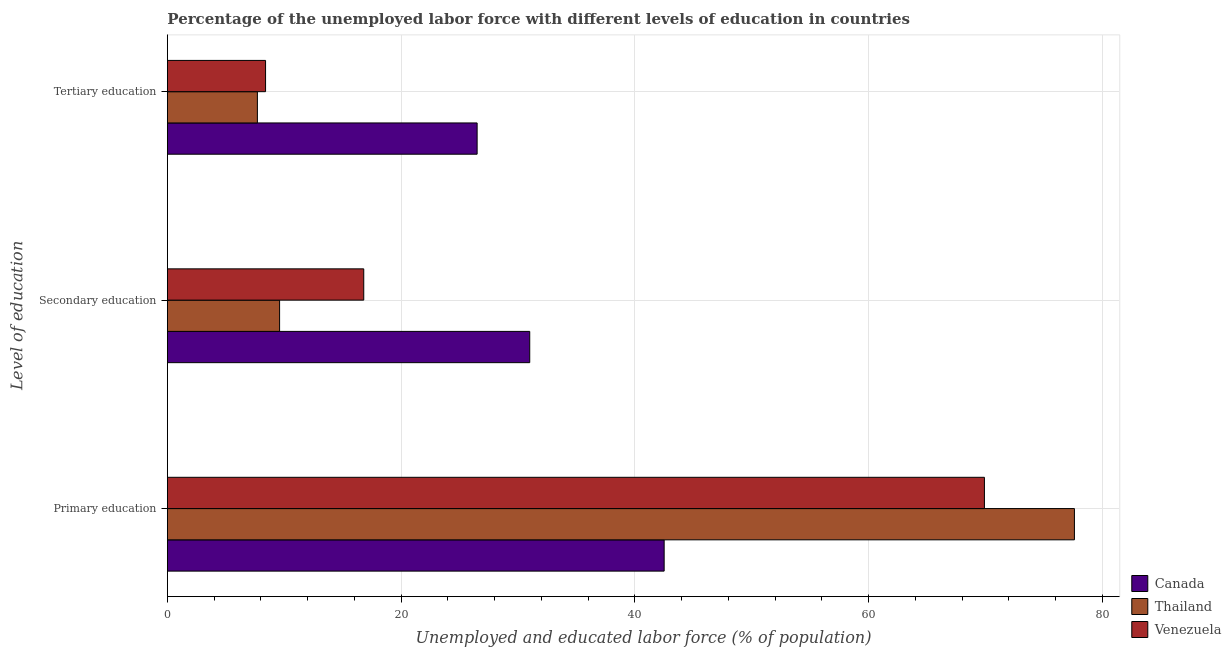How many different coloured bars are there?
Make the answer very short. 3. Are the number of bars per tick equal to the number of legend labels?
Give a very brief answer. Yes. How many bars are there on the 2nd tick from the top?
Offer a terse response. 3. How many bars are there on the 1st tick from the bottom?
Offer a terse response. 3. What is the label of the 2nd group of bars from the top?
Offer a terse response. Secondary education. What is the percentage of labor force who received tertiary education in Thailand?
Provide a succinct answer. 7.7. Across all countries, what is the maximum percentage of labor force who received primary education?
Ensure brevity in your answer.  77.6. Across all countries, what is the minimum percentage of labor force who received primary education?
Provide a succinct answer. 42.5. In which country was the percentage of labor force who received secondary education maximum?
Offer a very short reply. Canada. In which country was the percentage of labor force who received tertiary education minimum?
Make the answer very short. Thailand. What is the total percentage of labor force who received tertiary education in the graph?
Offer a terse response. 42.6. What is the difference between the percentage of labor force who received primary education in Venezuela and that in Canada?
Offer a very short reply. 27.4. What is the difference between the percentage of labor force who received primary education in Canada and the percentage of labor force who received secondary education in Thailand?
Your response must be concise. 32.9. What is the average percentage of labor force who received tertiary education per country?
Offer a terse response. 14.2. What is the ratio of the percentage of labor force who received tertiary education in Thailand to that in Canada?
Your answer should be compact. 0.29. What is the difference between the highest and the second highest percentage of labor force who received primary education?
Provide a short and direct response. 7.7. What is the difference between the highest and the lowest percentage of labor force who received tertiary education?
Your answer should be very brief. 18.8. What does the 1st bar from the top in Tertiary education represents?
Offer a very short reply. Venezuela. What does the 2nd bar from the bottom in Tertiary education represents?
Your response must be concise. Thailand. Is it the case that in every country, the sum of the percentage of labor force who received primary education and percentage of labor force who received secondary education is greater than the percentage of labor force who received tertiary education?
Your response must be concise. Yes. Are all the bars in the graph horizontal?
Your answer should be very brief. Yes. What is the title of the graph?
Make the answer very short. Percentage of the unemployed labor force with different levels of education in countries. Does "Bangladesh" appear as one of the legend labels in the graph?
Ensure brevity in your answer.  No. What is the label or title of the X-axis?
Offer a terse response. Unemployed and educated labor force (% of population). What is the label or title of the Y-axis?
Provide a short and direct response. Level of education. What is the Unemployed and educated labor force (% of population) of Canada in Primary education?
Keep it short and to the point. 42.5. What is the Unemployed and educated labor force (% of population) in Thailand in Primary education?
Make the answer very short. 77.6. What is the Unemployed and educated labor force (% of population) in Venezuela in Primary education?
Keep it short and to the point. 69.9. What is the Unemployed and educated labor force (% of population) in Thailand in Secondary education?
Make the answer very short. 9.6. What is the Unemployed and educated labor force (% of population) in Venezuela in Secondary education?
Your response must be concise. 16.8. What is the Unemployed and educated labor force (% of population) in Canada in Tertiary education?
Your response must be concise. 26.5. What is the Unemployed and educated labor force (% of population) in Thailand in Tertiary education?
Provide a short and direct response. 7.7. What is the Unemployed and educated labor force (% of population) in Venezuela in Tertiary education?
Ensure brevity in your answer.  8.4. Across all Level of education, what is the maximum Unemployed and educated labor force (% of population) of Canada?
Ensure brevity in your answer.  42.5. Across all Level of education, what is the maximum Unemployed and educated labor force (% of population) of Thailand?
Provide a short and direct response. 77.6. Across all Level of education, what is the maximum Unemployed and educated labor force (% of population) of Venezuela?
Keep it short and to the point. 69.9. Across all Level of education, what is the minimum Unemployed and educated labor force (% of population) of Canada?
Your answer should be very brief. 26.5. Across all Level of education, what is the minimum Unemployed and educated labor force (% of population) of Thailand?
Your answer should be compact. 7.7. Across all Level of education, what is the minimum Unemployed and educated labor force (% of population) of Venezuela?
Your answer should be very brief. 8.4. What is the total Unemployed and educated labor force (% of population) in Thailand in the graph?
Your answer should be compact. 94.9. What is the total Unemployed and educated labor force (% of population) of Venezuela in the graph?
Your response must be concise. 95.1. What is the difference between the Unemployed and educated labor force (% of population) of Thailand in Primary education and that in Secondary education?
Make the answer very short. 68. What is the difference between the Unemployed and educated labor force (% of population) in Venezuela in Primary education and that in Secondary education?
Provide a succinct answer. 53.1. What is the difference between the Unemployed and educated labor force (% of population) of Canada in Primary education and that in Tertiary education?
Your answer should be compact. 16. What is the difference between the Unemployed and educated labor force (% of population) of Thailand in Primary education and that in Tertiary education?
Your answer should be compact. 69.9. What is the difference between the Unemployed and educated labor force (% of population) in Venezuela in Primary education and that in Tertiary education?
Ensure brevity in your answer.  61.5. What is the difference between the Unemployed and educated labor force (% of population) of Canada in Primary education and the Unemployed and educated labor force (% of population) of Thailand in Secondary education?
Offer a very short reply. 32.9. What is the difference between the Unemployed and educated labor force (% of population) of Canada in Primary education and the Unemployed and educated labor force (% of population) of Venezuela in Secondary education?
Provide a succinct answer. 25.7. What is the difference between the Unemployed and educated labor force (% of population) of Thailand in Primary education and the Unemployed and educated labor force (% of population) of Venezuela in Secondary education?
Provide a short and direct response. 60.8. What is the difference between the Unemployed and educated labor force (% of population) of Canada in Primary education and the Unemployed and educated labor force (% of population) of Thailand in Tertiary education?
Ensure brevity in your answer.  34.8. What is the difference between the Unemployed and educated labor force (% of population) in Canada in Primary education and the Unemployed and educated labor force (% of population) in Venezuela in Tertiary education?
Offer a very short reply. 34.1. What is the difference between the Unemployed and educated labor force (% of population) of Thailand in Primary education and the Unemployed and educated labor force (% of population) of Venezuela in Tertiary education?
Ensure brevity in your answer.  69.2. What is the difference between the Unemployed and educated labor force (% of population) in Canada in Secondary education and the Unemployed and educated labor force (% of population) in Thailand in Tertiary education?
Give a very brief answer. 23.3. What is the difference between the Unemployed and educated labor force (% of population) of Canada in Secondary education and the Unemployed and educated labor force (% of population) of Venezuela in Tertiary education?
Ensure brevity in your answer.  22.6. What is the average Unemployed and educated labor force (% of population) in Canada per Level of education?
Your answer should be compact. 33.33. What is the average Unemployed and educated labor force (% of population) in Thailand per Level of education?
Your answer should be compact. 31.63. What is the average Unemployed and educated labor force (% of population) of Venezuela per Level of education?
Provide a succinct answer. 31.7. What is the difference between the Unemployed and educated labor force (% of population) in Canada and Unemployed and educated labor force (% of population) in Thailand in Primary education?
Offer a terse response. -35.1. What is the difference between the Unemployed and educated labor force (% of population) in Canada and Unemployed and educated labor force (% of population) in Venezuela in Primary education?
Give a very brief answer. -27.4. What is the difference between the Unemployed and educated labor force (% of population) in Thailand and Unemployed and educated labor force (% of population) in Venezuela in Primary education?
Your response must be concise. 7.7. What is the difference between the Unemployed and educated labor force (% of population) in Canada and Unemployed and educated labor force (% of population) in Thailand in Secondary education?
Provide a succinct answer. 21.4. What is the difference between the Unemployed and educated labor force (% of population) in Thailand and Unemployed and educated labor force (% of population) in Venezuela in Secondary education?
Your response must be concise. -7.2. What is the difference between the Unemployed and educated labor force (% of population) in Thailand and Unemployed and educated labor force (% of population) in Venezuela in Tertiary education?
Provide a short and direct response. -0.7. What is the ratio of the Unemployed and educated labor force (% of population) of Canada in Primary education to that in Secondary education?
Offer a terse response. 1.37. What is the ratio of the Unemployed and educated labor force (% of population) in Thailand in Primary education to that in Secondary education?
Keep it short and to the point. 8.08. What is the ratio of the Unemployed and educated labor force (% of population) of Venezuela in Primary education to that in Secondary education?
Make the answer very short. 4.16. What is the ratio of the Unemployed and educated labor force (% of population) of Canada in Primary education to that in Tertiary education?
Keep it short and to the point. 1.6. What is the ratio of the Unemployed and educated labor force (% of population) of Thailand in Primary education to that in Tertiary education?
Offer a very short reply. 10.08. What is the ratio of the Unemployed and educated labor force (% of population) of Venezuela in Primary education to that in Tertiary education?
Provide a succinct answer. 8.32. What is the ratio of the Unemployed and educated labor force (% of population) in Canada in Secondary education to that in Tertiary education?
Make the answer very short. 1.17. What is the ratio of the Unemployed and educated labor force (% of population) in Thailand in Secondary education to that in Tertiary education?
Give a very brief answer. 1.25. What is the ratio of the Unemployed and educated labor force (% of population) in Venezuela in Secondary education to that in Tertiary education?
Give a very brief answer. 2. What is the difference between the highest and the second highest Unemployed and educated labor force (% of population) of Canada?
Your answer should be compact. 11.5. What is the difference between the highest and the second highest Unemployed and educated labor force (% of population) in Venezuela?
Offer a terse response. 53.1. What is the difference between the highest and the lowest Unemployed and educated labor force (% of population) of Canada?
Make the answer very short. 16. What is the difference between the highest and the lowest Unemployed and educated labor force (% of population) in Thailand?
Give a very brief answer. 69.9. What is the difference between the highest and the lowest Unemployed and educated labor force (% of population) in Venezuela?
Provide a succinct answer. 61.5. 